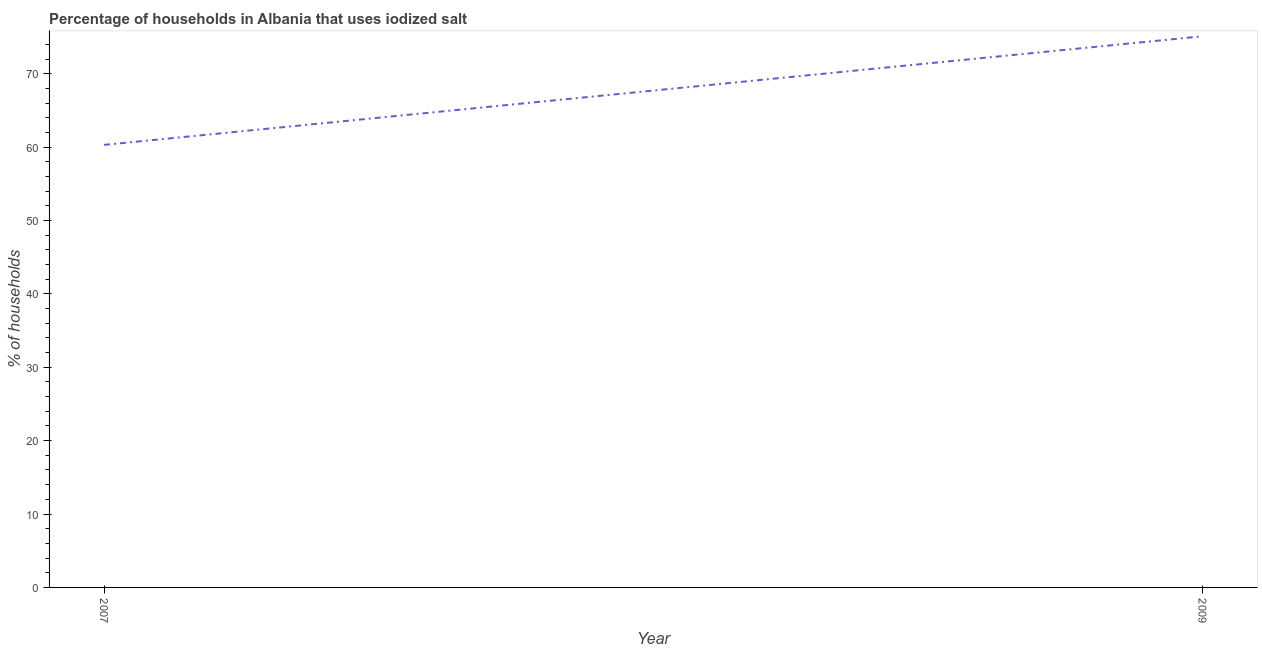What is the percentage of households where iodized salt is consumed in 2009?
Your answer should be compact. 75.1. Across all years, what is the maximum percentage of households where iodized salt is consumed?
Your answer should be very brief. 75.1. Across all years, what is the minimum percentage of households where iodized salt is consumed?
Provide a short and direct response. 60.3. What is the sum of the percentage of households where iodized salt is consumed?
Offer a very short reply. 135.4. What is the difference between the percentage of households where iodized salt is consumed in 2007 and 2009?
Provide a succinct answer. -14.8. What is the average percentage of households where iodized salt is consumed per year?
Offer a very short reply. 67.7. What is the median percentage of households where iodized salt is consumed?
Your answer should be compact. 67.7. In how many years, is the percentage of households where iodized salt is consumed greater than 64 %?
Provide a short and direct response. 1. What is the ratio of the percentage of households where iodized salt is consumed in 2007 to that in 2009?
Provide a short and direct response. 0.8. Is the percentage of households where iodized salt is consumed in 2007 less than that in 2009?
Make the answer very short. Yes. Does the graph contain grids?
Keep it short and to the point. No. What is the title of the graph?
Make the answer very short. Percentage of households in Albania that uses iodized salt. What is the label or title of the Y-axis?
Your answer should be very brief. % of households. What is the % of households of 2007?
Ensure brevity in your answer.  60.3. What is the % of households in 2009?
Give a very brief answer. 75.1. What is the difference between the % of households in 2007 and 2009?
Provide a short and direct response. -14.8. What is the ratio of the % of households in 2007 to that in 2009?
Give a very brief answer. 0.8. 